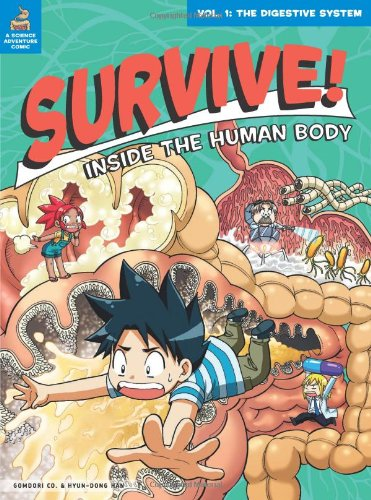Is this book related to Children's Books? Absolutely! This book is a perfect fit for the Children's Books genre, with its colorful illustrations and educational storytelling ideal for young audiences. 